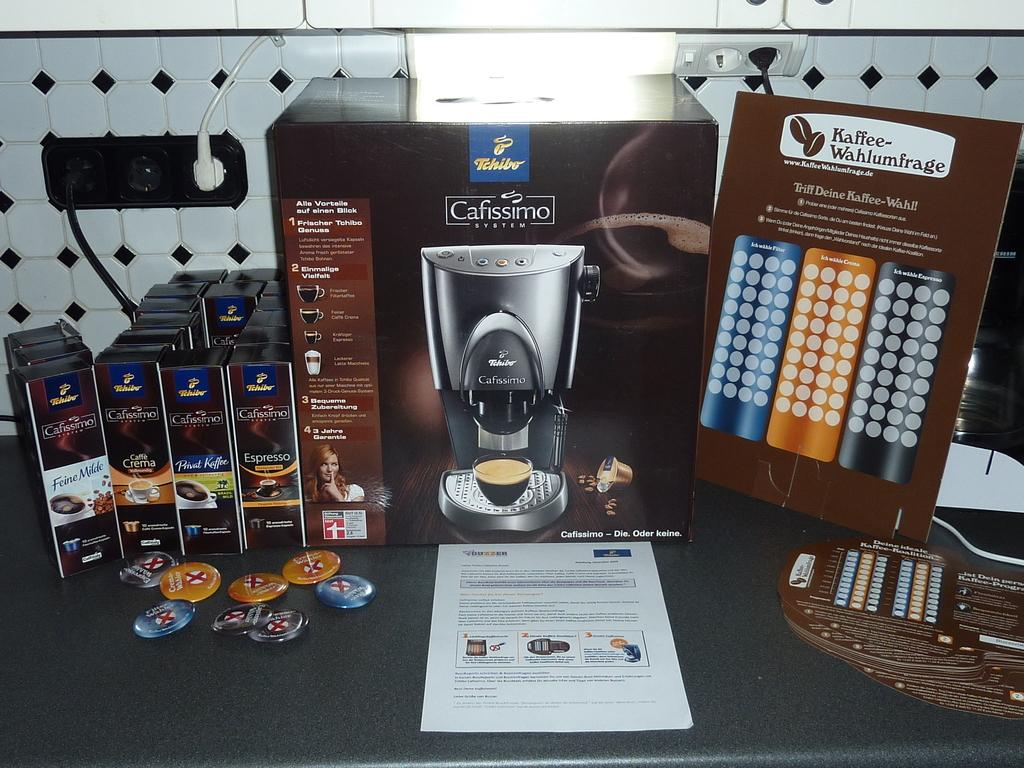<image>
Describe the image concisely. Cafissimo System reads the brand of this coffee machine. 